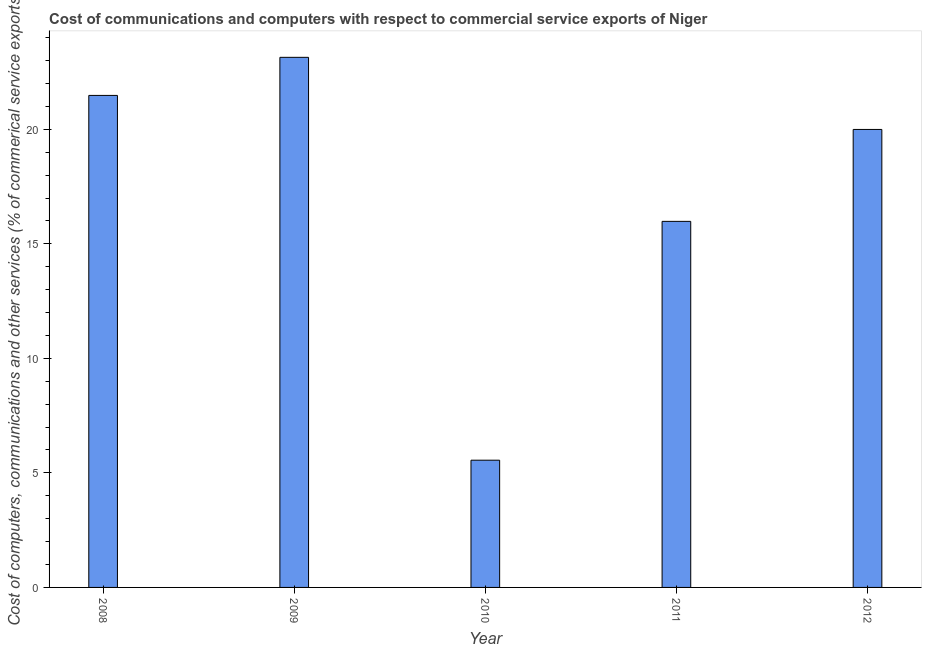What is the title of the graph?
Offer a terse response. Cost of communications and computers with respect to commercial service exports of Niger. What is the label or title of the X-axis?
Offer a terse response. Year. What is the label or title of the Y-axis?
Keep it short and to the point. Cost of computers, communications and other services (% of commerical service exports). What is the cost of communications in 2011?
Provide a succinct answer. 15.98. Across all years, what is the maximum  computer and other services?
Make the answer very short. 23.14. Across all years, what is the minimum  computer and other services?
Make the answer very short. 5.55. What is the sum of the  computer and other services?
Provide a succinct answer. 86.15. What is the difference between the cost of communications in 2011 and 2012?
Make the answer very short. -4.01. What is the average cost of communications per year?
Make the answer very short. 17.23. What is the median cost of communications?
Your answer should be compact. 19.99. In how many years, is the cost of communications greater than 5 %?
Offer a very short reply. 5. What is the ratio of the  computer and other services in 2008 to that in 2011?
Make the answer very short. 1.34. Is the cost of communications in 2009 less than that in 2011?
Offer a very short reply. No. Is the difference between the  computer and other services in 2008 and 2009 greater than the difference between any two years?
Offer a terse response. No. What is the difference between the highest and the second highest  computer and other services?
Offer a terse response. 1.66. What is the difference between the highest and the lowest  computer and other services?
Provide a succinct answer. 17.59. In how many years, is the cost of communications greater than the average cost of communications taken over all years?
Make the answer very short. 3. How many bars are there?
Your response must be concise. 5. Are all the bars in the graph horizontal?
Ensure brevity in your answer.  No. Are the values on the major ticks of Y-axis written in scientific E-notation?
Provide a succinct answer. No. What is the Cost of computers, communications and other services (% of commerical service exports) of 2008?
Your answer should be very brief. 21.48. What is the Cost of computers, communications and other services (% of commerical service exports) in 2009?
Your answer should be very brief. 23.14. What is the Cost of computers, communications and other services (% of commerical service exports) in 2010?
Provide a short and direct response. 5.55. What is the Cost of computers, communications and other services (% of commerical service exports) in 2011?
Offer a very short reply. 15.98. What is the Cost of computers, communications and other services (% of commerical service exports) of 2012?
Give a very brief answer. 19.99. What is the difference between the Cost of computers, communications and other services (% of commerical service exports) in 2008 and 2009?
Provide a short and direct response. -1.66. What is the difference between the Cost of computers, communications and other services (% of commerical service exports) in 2008 and 2010?
Make the answer very short. 15.93. What is the difference between the Cost of computers, communications and other services (% of commerical service exports) in 2008 and 2011?
Your answer should be compact. 5.5. What is the difference between the Cost of computers, communications and other services (% of commerical service exports) in 2008 and 2012?
Provide a short and direct response. 1.49. What is the difference between the Cost of computers, communications and other services (% of commerical service exports) in 2009 and 2010?
Ensure brevity in your answer.  17.59. What is the difference between the Cost of computers, communications and other services (% of commerical service exports) in 2009 and 2011?
Keep it short and to the point. 7.16. What is the difference between the Cost of computers, communications and other services (% of commerical service exports) in 2009 and 2012?
Give a very brief answer. 3.15. What is the difference between the Cost of computers, communications and other services (% of commerical service exports) in 2010 and 2011?
Provide a succinct answer. -10.43. What is the difference between the Cost of computers, communications and other services (% of commerical service exports) in 2010 and 2012?
Your response must be concise. -14.44. What is the difference between the Cost of computers, communications and other services (% of commerical service exports) in 2011 and 2012?
Make the answer very short. -4.01. What is the ratio of the Cost of computers, communications and other services (% of commerical service exports) in 2008 to that in 2009?
Offer a very short reply. 0.93. What is the ratio of the Cost of computers, communications and other services (% of commerical service exports) in 2008 to that in 2010?
Offer a terse response. 3.87. What is the ratio of the Cost of computers, communications and other services (% of commerical service exports) in 2008 to that in 2011?
Ensure brevity in your answer.  1.34. What is the ratio of the Cost of computers, communications and other services (% of commerical service exports) in 2008 to that in 2012?
Your response must be concise. 1.07. What is the ratio of the Cost of computers, communications and other services (% of commerical service exports) in 2009 to that in 2010?
Offer a terse response. 4.17. What is the ratio of the Cost of computers, communications and other services (% of commerical service exports) in 2009 to that in 2011?
Provide a short and direct response. 1.45. What is the ratio of the Cost of computers, communications and other services (% of commerical service exports) in 2009 to that in 2012?
Give a very brief answer. 1.16. What is the ratio of the Cost of computers, communications and other services (% of commerical service exports) in 2010 to that in 2011?
Keep it short and to the point. 0.35. What is the ratio of the Cost of computers, communications and other services (% of commerical service exports) in 2010 to that in 2012?
Make the answer very short. 0.28. What is the ratio of the Cost of computers, communications and other services (% of commerical service exports) in 2011 to that in 2012?
Offer a very short reply. 0.8. 